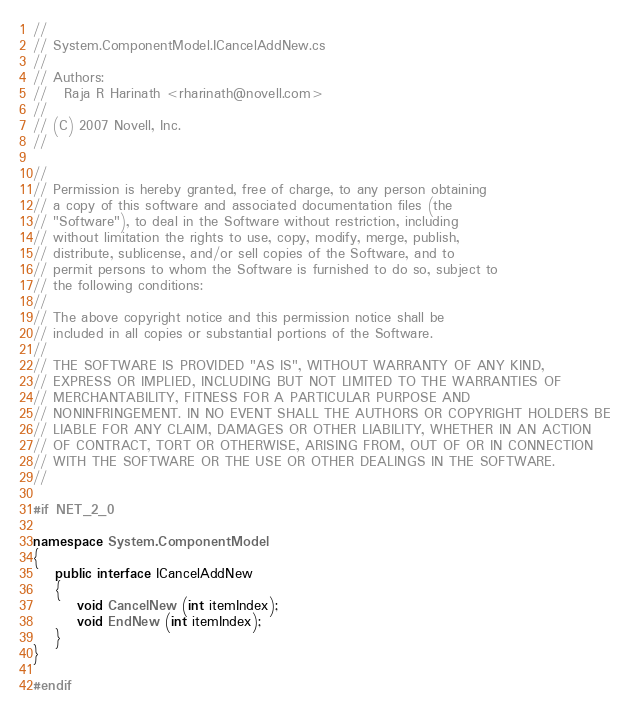<code> <loc_0><loc_0><loc_500><loc_500><_C#_>//
// System.ComponentModel.ICancelAddNew.cs
//
// Authors:
//   Raja R Harinath <rharinath@novell.com>
//
// (C) 2007 Novell, Inc.
//

//
// Permission is hereby granted, free of charge, to any person obtaining
// a copy of this software and associated documentation files (the
// "Software"), to deal in the Software without restriction, including
// without limitation the rights to use, copy, modify, merge, publish,
// distribute, sublicense, and/or sell copies of the Software, and to
// permit persons to whom the Software is furnished to do so, subject to
// the following conditions:
// 
// The above copyright notice and this permission notice shall be
// included in all copies or substantial portions of the Software.
// 
// THE SOFTWARE IS PROVIDED "AS IS", WITHOUT WARRANTY OF ANY KIND,
// EXPRESS OR IMPLIED, INCLUDING BUT NOT LIMITED TO THE WARRANTIES OF
// MERCHANTABILITY, FITNESS FOR A PARTICULAR PURPOSE AND
// NONINFRINGEMENT. IN NO EVENT SHALL THE AUTHORS OR COPYRIGHT HOLDERS BE
// LIABLE FOR ANY CLAIM, DAMAGES OR OTHER LIABILITY, WHETHER IN AN ACTION
// OF CONTRACT, TORT OR OTHERWISE, ARISING FROM, OUT OF OR IN CONNECTION
// WITH THE SOFTWARE OR THE USE OR OTHER DEALINGS IN THE SOFTWARE.
//

#if NET_2_0

namespace System.ComponentModel
{
	public interface ICancelAddNew
	{
		void CancelNew (int itemIndex);
		void EndNew (int itemIndex);
	}
}

#endif
</code> 